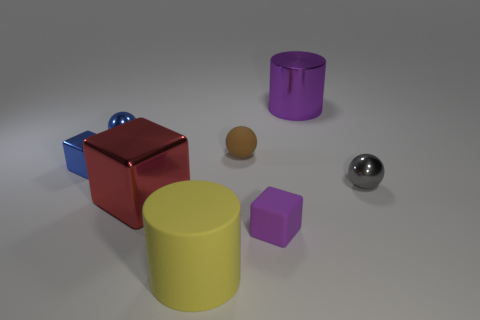There is a block that is the same color as the large shiny cylinder; what size is it?
Make the answer very short. Small. What is the color of the rubber block that is the same size as the brown sphere?
Your response must be concise. Purple. There is another metallic thing that is the same shape as the gray object; what color is it?
Make the answer very short. Blue. What is the ball to the right of the tiny matte block made of?
Ensure brevity in your answer.  Metal. What number of other objects are there of the same shape as the brown object?
Ensure brevity in your answer.  2. Is the tiny gray thing the same shape as the small brown object?
Your answer should be compact. Yes. There is a brown thing; are there any small rubber objects in front of it?
Keep it short and to the point. Yes. How many objects are tiny red balls or big purple metal things?
Offer a very short reply. 1. How many other objects are the same size as the purple shiny cylinder?
Offer a very short reply. 2. How many objects are both behind the red block and to the left of the tiny gray sphere?
Provide a succinct answer. 4. 